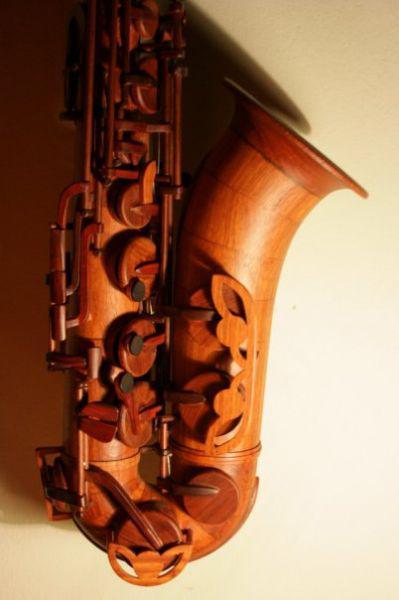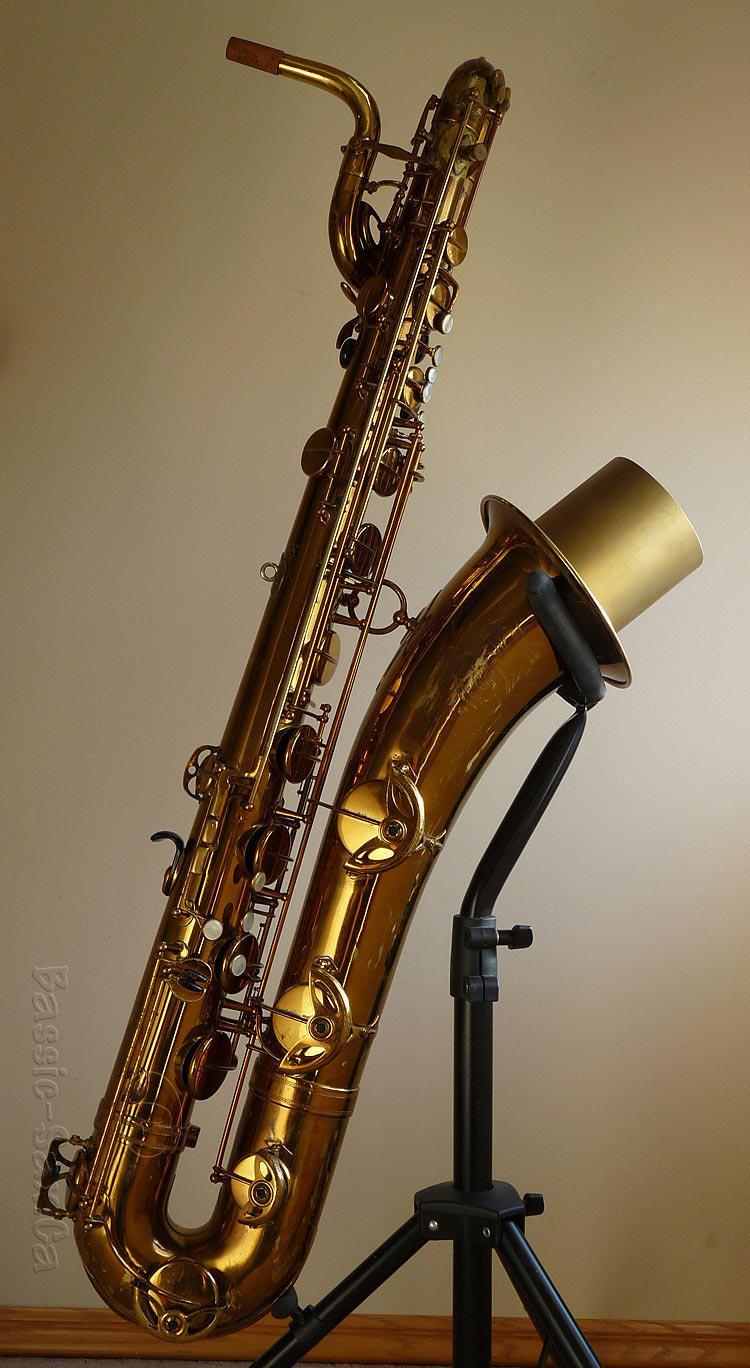The first image is the image on the left, the second image is the image on the right. Examine the images to the left and right. Is the description "The left image shows one instrument on a white background." accurate? Answer yes or no. No. 